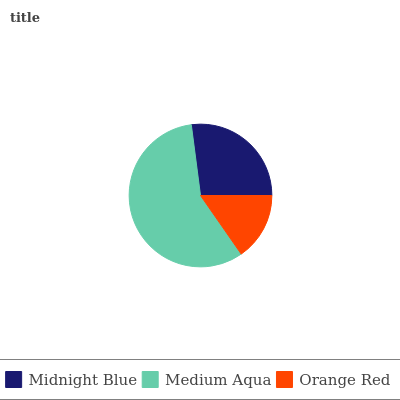Is Orange Red the minimum?
Answer yes or no. Yes. Is Medium Aqua the maximum?
Answer yes or no. Yes. Is Medium Aqua the minimum?
Answer yes or no. No. Is Orange Red the maximum?
Answer yes or no. No. Is Medium Aqua greater than Orange Red?
Answer yes or no. Yes. Is Orange Red less than Medium Aqua?
Answer yes or no. Yes. Is Orange Red greater than Medium Aqua?
Answer yes or no. No. Is Medium Aqua less than Orange Red?
Answer yes or no. No. Is Midnight Blue the high median?
Answer yes or no. Yes. Is Midnight Blue the low median?
Answer yes or no. Yes. Is Medium Aqua the high median?
Answer yes or no. No. Is Orange Red the low median?
Answer yes or no. No. 